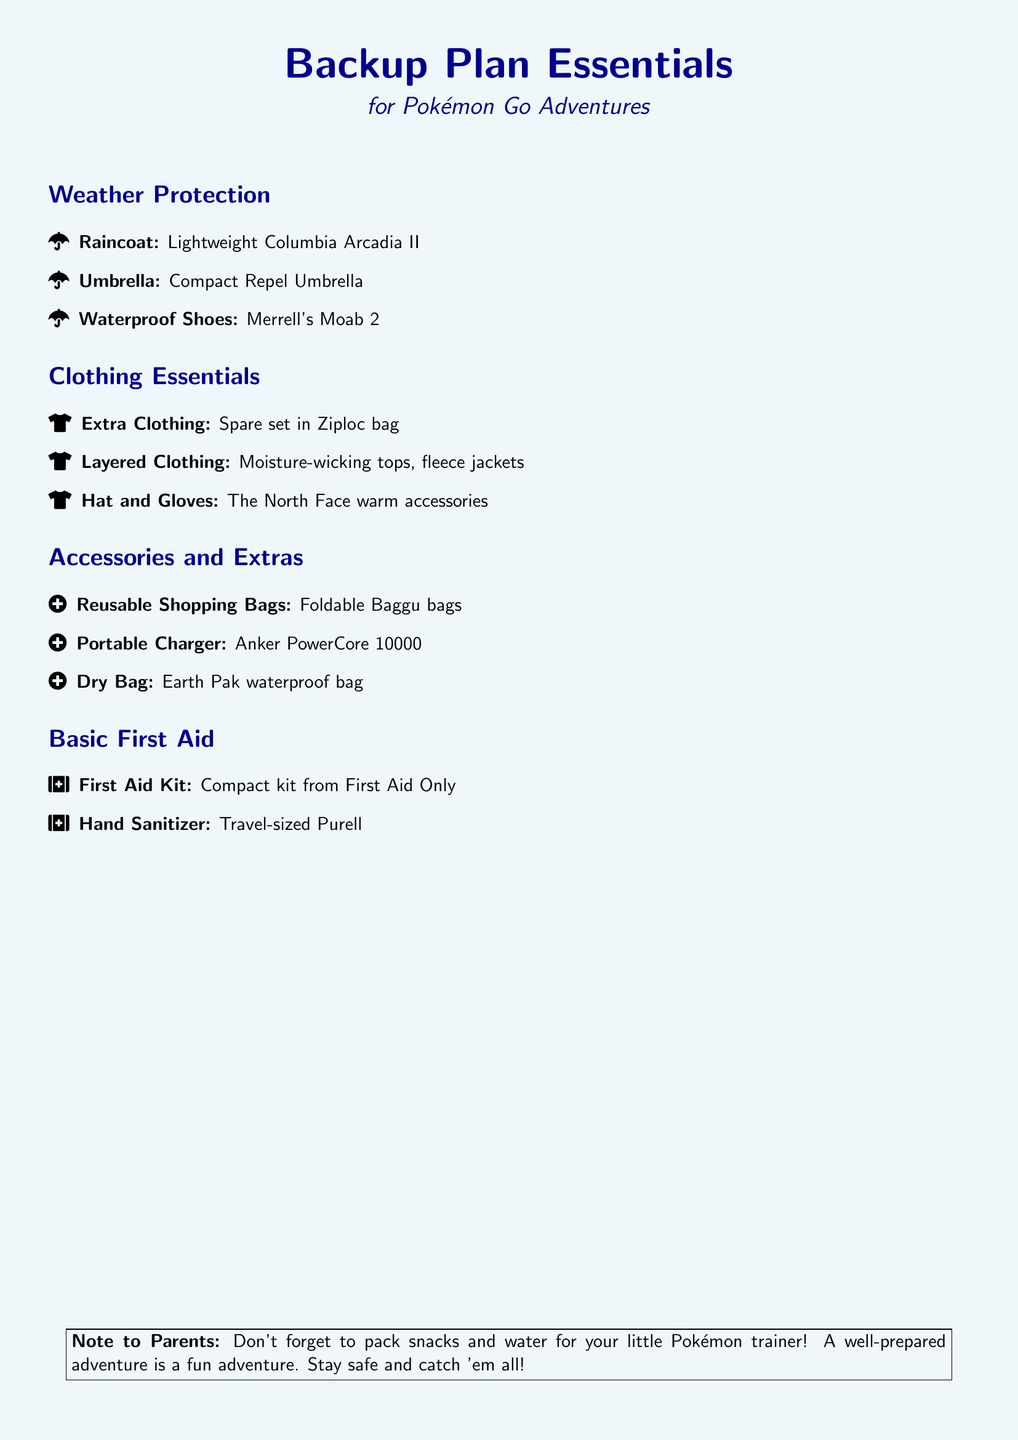What is the main title of the document? The main title is the first line in the document, which indicates the content's focus, "Backup Plan Essentials."
Answer: Backup Plan Essentials What type of clothing is suggested for unexpected weather? The document lists clothing items specifically aimed at protecting against weather changes, such as "Spare set in Ziploc bag."
Answer: Spare set in Ziploc bag How many essential areas are covered in the document? The document is divided into four main sections: Weather Protection, Clothing Essentials, Accessories and Extras, and Basic First Aid, indicating a total of four areas.
Answer: Four What is one type of waterproof footwear mentioned? The document specifies a variety of waterproof footwear, highlighting "Merrell's Moab 2."
Answer: Merrell's Moab 2 What is included in the Accessories and Extras section? This section includes various items useful for outdoor activities, specifically stating "Reusable Shopping Bags: Foldable Baggu bags."
Answer: Foldable Baggu bags What should parents not forget to pack? The note directed towards parents emphasizes the importance of snacks and water for their child while playing outside.
Answer: Snacks and water Which brand offers a compact First Aid kit? The document names a specific brand for the First Aid kit, which is "First Aid Only."
Answer: First Aid Only What type of bag is recommended for keeping items dry? The document specifies a particular type of bag designed for this purpose named "Earth Pak waterproof bag."
Answer: Earth Pak waterproof bag 